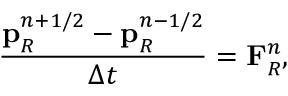Convert formula to latex. <formula><loc_0><loc_0><loc_500><loc_500>\frac { p _ { R } ^ { n + 1 / 2 } - p _ { R } ^ { n - 1 / 2 } } { \Delta t } = F _ { R } ^ { n } ,</formula> 